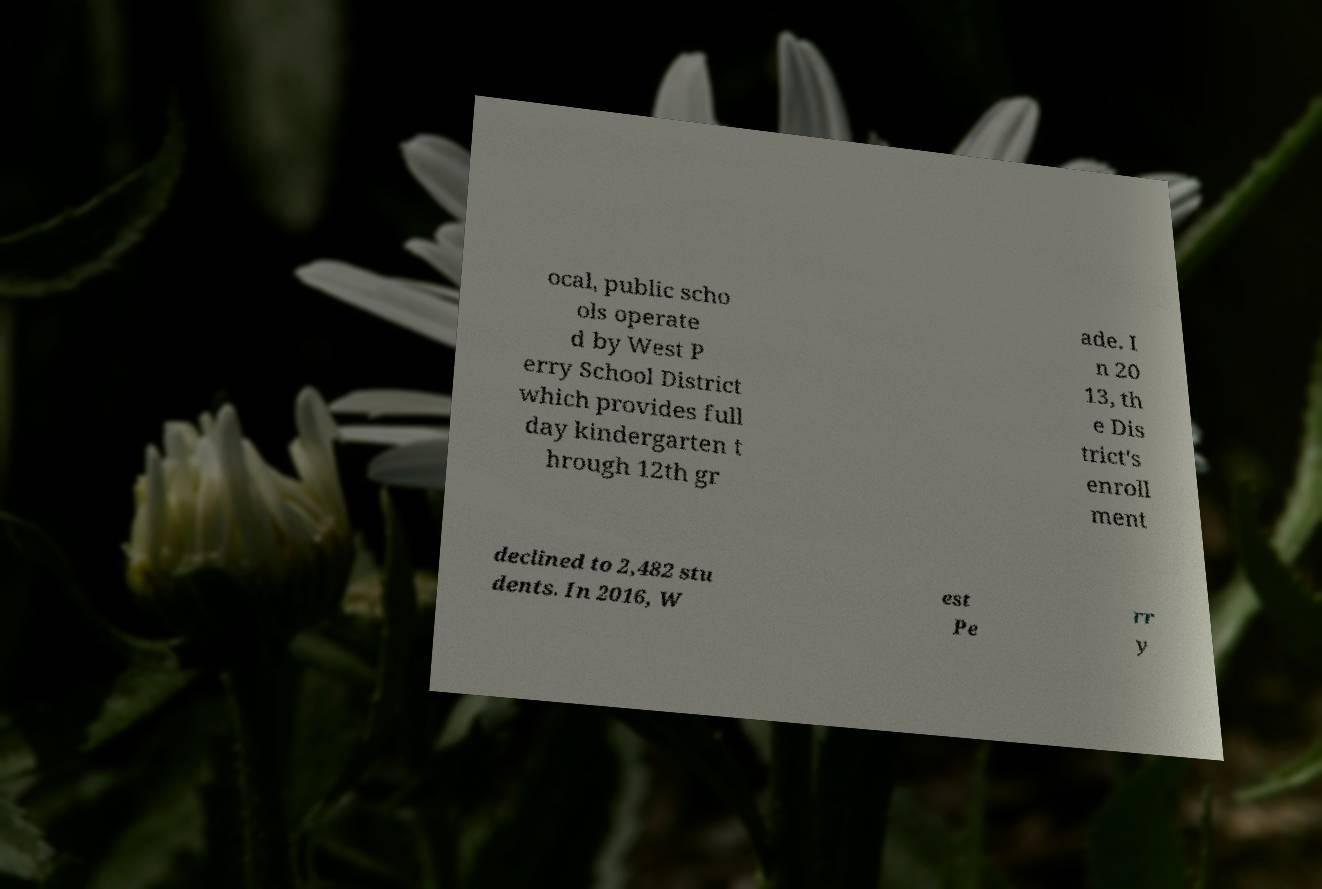Could you assist in decoding the text presented in this image and type it out clearly? ocal, public scho ols operate d by West P erry School District which provides full day kindergarten t hrough 12th gr ade. I n 20 13, th e Dis trict's enroll ment declined to 2,482 stu dents. In 2016, W est Pe rr y 